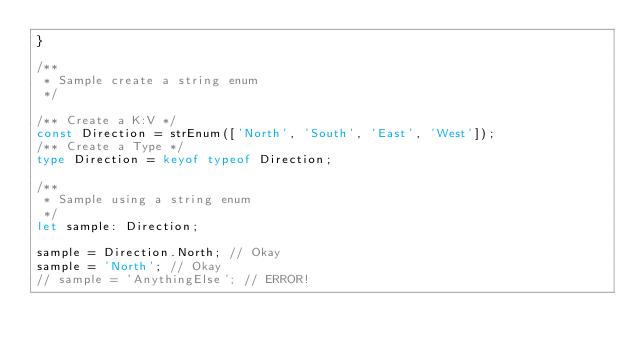<code> <loc_0><loc_0><loc_500><loc_500><_TypeScript_>}

/**
 * Sample create a string enum
 */

/** Create a K:V */
const Direction = strEnum(['North', 'South', 'East', 'West']);
/** Create a Type */
type Direction = keyof typeof Direction;

/**
 * Sample using a string enum
 */
let sample: Direction;

sample = Direction.North; // Okay
sample = 'North'; // Okay
// sample = 'AnythingElse'; // ERROR!
</code> 